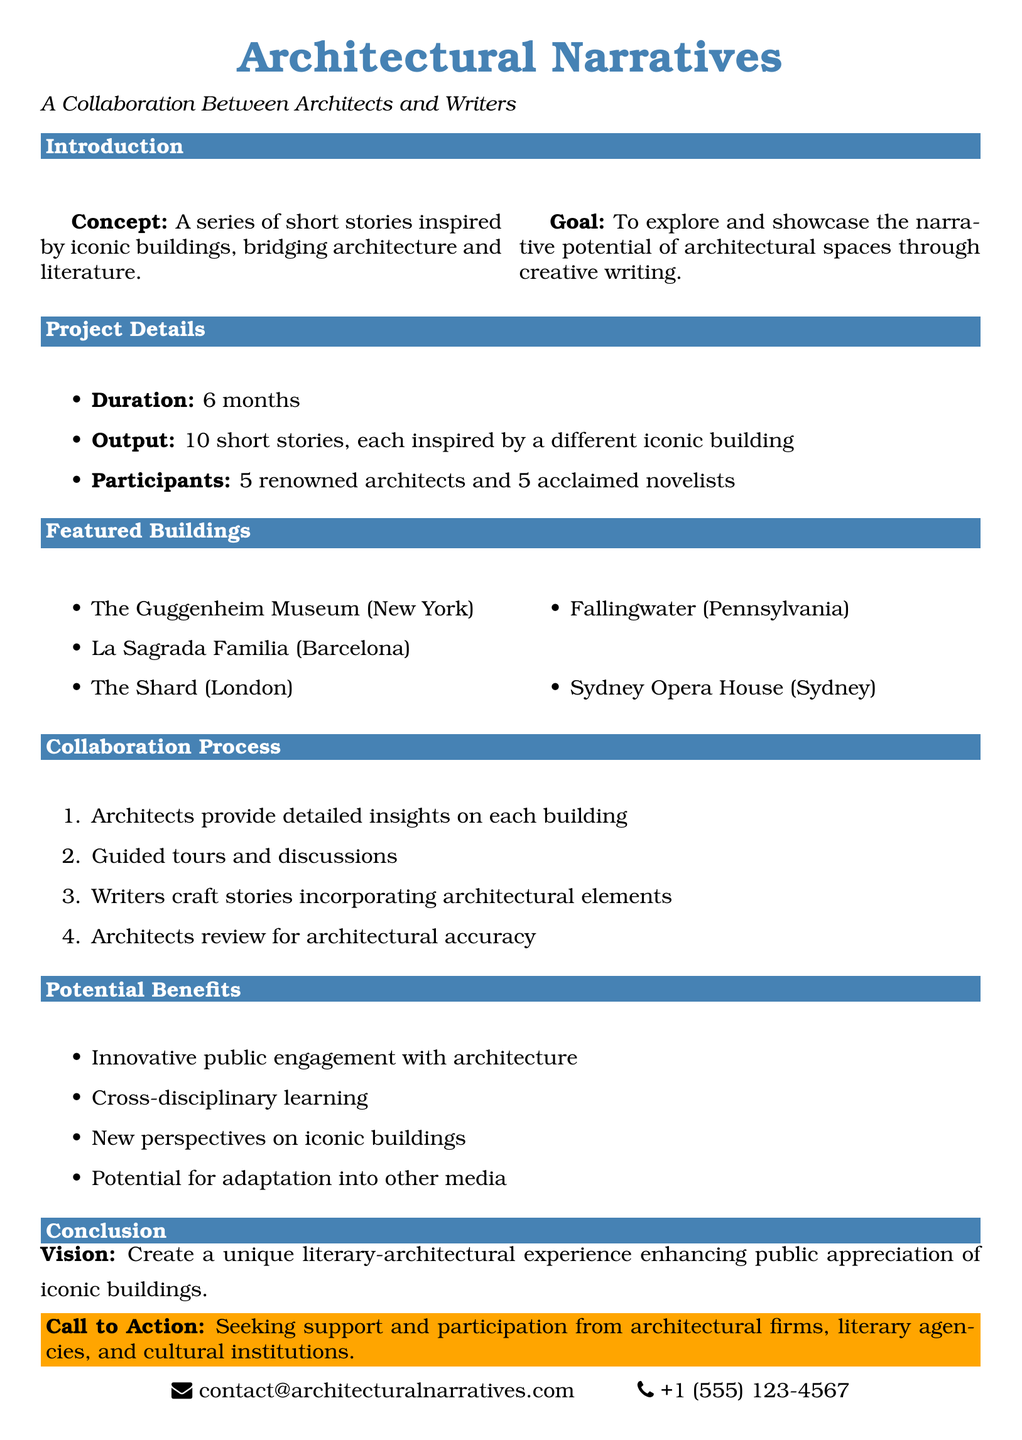What is the title of the project? The title of the project is explicitly stated in the document as "Architectural Narratives."
Answer: Architectural Narratives How many short stories will be produced? The document mentions that the output will be "10 short stories."
Answer: 10 short stories Who are the participants in the project? The document lists the participants as "5 renowned architects and 5 acclaimed novelists."
Answer: 5 renowned architects and 5 acclaimed novelists What is the duration of the project? The duration of the project is specified as "6 months."
Answer: 6 months What is one of the potential benefits of this collaboration? The document highlights "cross-disciplinary learning" as one potential benefit.
Answer: Cross-disciplinary learning In which city is La Sagrada Familia located? The document identifies the location of La Sagrada Familia as "Barcelona."
Answer: Barcelona What is the call to action in the conclusion? The call to action in the conclusion is to seek "support and participation from architectural firms, literary agencies, and cultural institutions."
Answer: Support and participation from architectural firms, literary agencies, and cultural institutions What is the main concept of the project? The main concept is described as "a series of short stories inspired by iconic buildings."
Answer: A series of short stories inspired by iconic buildings What is the purpose of the guided tours in the collaboration process? The guided tours are meant for "writers and architects to engage in discussions."
Answer: Writers and architects to engage in discussions 